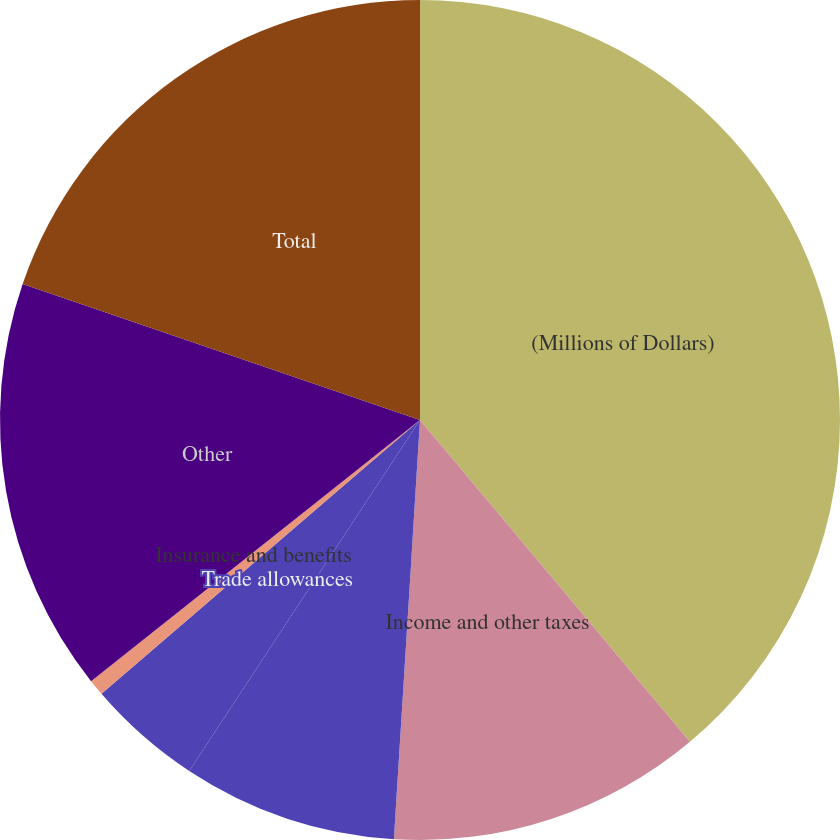<chart> <loc_0><loc_0><loc_500><loc_500><pie_chart><fcel>(Millions of Dollars)<fcel>Income and other taxes<fcel>Payroll and related taxes<fcel>Trade allowances<fcel>Insurance and benefits<fcel>Other<fcel>Total<nl><fcel>38.89%<fcel>12.1%<fcel>8.27%<fcel>4.44%<fcel>0.62%<fcel>15.93%<fcel>19.75%<nl></chart> 